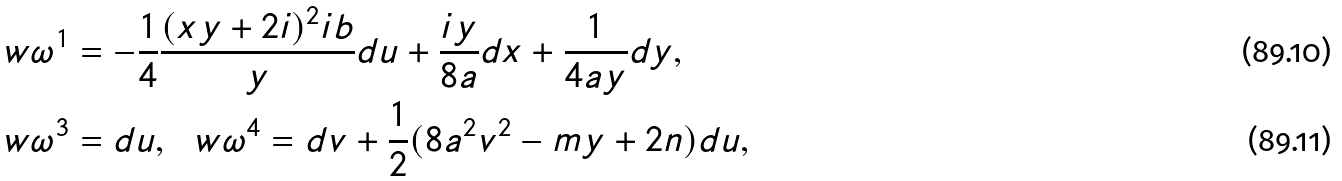Convert formula to latex. <formula><loc_0><loc_0><loc_500><loc_500>\ w { \omega } ^ { 1 } & = - \frac { 1 } { 4 } \frac { ( x y + 2 i ) ^ { 2 } i b } { y } d u + \frac { i y } { 8 a } d x + \frac { 1 } { 4 a y } d y , \\ \ w { \omega } ^ { 3 } & = d u , \ \ w { \omega } ^ { 4 } = d v + \frac { 1 } { 2 } ( 8 a ^ { 2 } v ^ { 2 } - m y + 2 n ) d u ,</formula> 